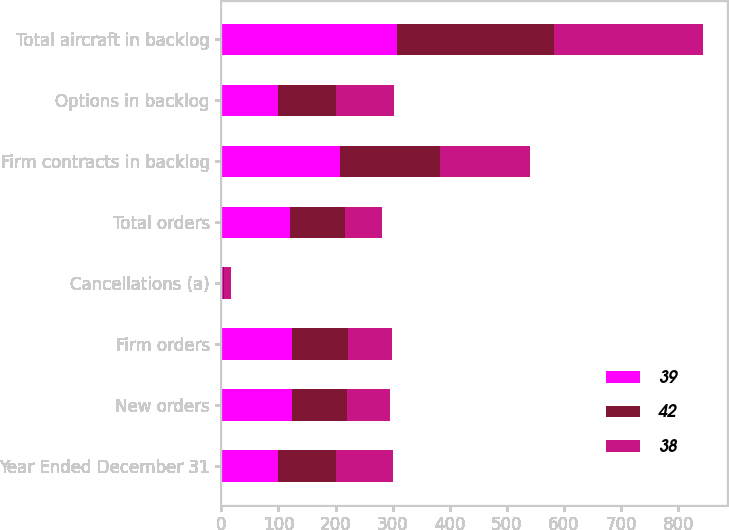<chart> <loc_0><loc_0><loc_500><loc_500><stacked_bar_chart><ecel><fcel>Year Ended December 31<fcel>New orders<fcel>Firm orders<fcel>Cancellations (a)<fcel>Total orders<fcel>Firm contracts in backlog<fcel>Options in backlog<fcel>Total aircraft in backlog<nl><fcel>39<fcel>100<fcel>124<fcel>124<fcel>3<fcel>121<fcel>207<fcel>100<fcel>307<nl><fcel>42<fcel>100<fcel>96<fcel>97<fcel>2<fcel>95<fcel>175<fcel>100<fcel>275<nl><fcel>38<fcel>100<fcel>75<fcel>78<fcel>12<fcel>66<fcel>158<fcel>103<fcel>261<nl></chart> 